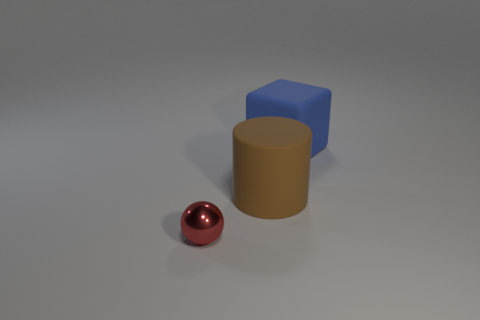Is there any other thing that has the same material as the small sphere?
Your response must be concise. No. What is the material of the red thing in front of the big rubber object in front of the large rubber thing behind the big brown rubber object?
Give a very brief answer. Metal. Are there an equal number of big blocks behind the big brown matte object and yellow metallic things?
Give a very brief answer. No. Is the large object that is to the right of the big brown rubber thing made of the same material as the big object that is in front of the blue rubber object?
Your response must be concise. Yes. What number of objects are large blue matte blocks or objects behind the small red ball?
Your answer should be very brief. 2. Are there any other metallic objects that have the same shape as the large blue thing?
Keep it short and to the point. No. What size is the matte thing to the left of the thing that is right of the matte object that is in front of the blue block?
Your answer should be compact. Large. Are there an equal number of blue blocks in front of the big blue thing and objects to the left of the tiny thing?
Your answer should be very brief. Yes. The brown object that is the same material as the large block is what size?
Provide a short and direct response. Large. The big rubber cylinder is what color?
Ensure brevity in your answer.  Brown. 